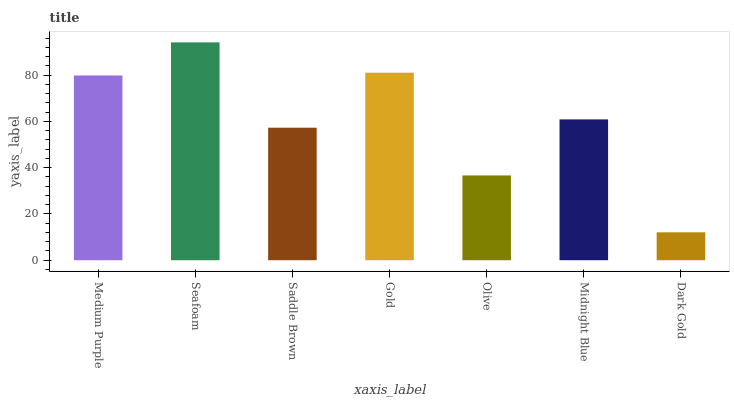Is Dark Gold the minimum?
Answer yes or no. Yes. Is Seafoam the maximum?
Answer yes or no. Yes. Is Saddle Brown the minimum?
Answer yes or no. No. Is Saddle Brown the maximum?
Answer yes or no. No. Is Seafoam greater than Saddle Brown?
Answer yes or no. Yes. Is Saddle Brown less than Seafoam?
Answer yes or no. Yes. Is Saddle Brown greater than Seafoam?
Answer yes or no. No. Is Seafoam less than Saddle Brown?
Answer yes or no. No. Is Midnight Blue the high median?
Answer yes or no. Yes. Is Midnight Blue the low median?
Answer yes or no. Yes. Is Medium Purple the high median?
Answer yes or no. No. Is Dark Gold the low median?
Answer yes or no. No. 